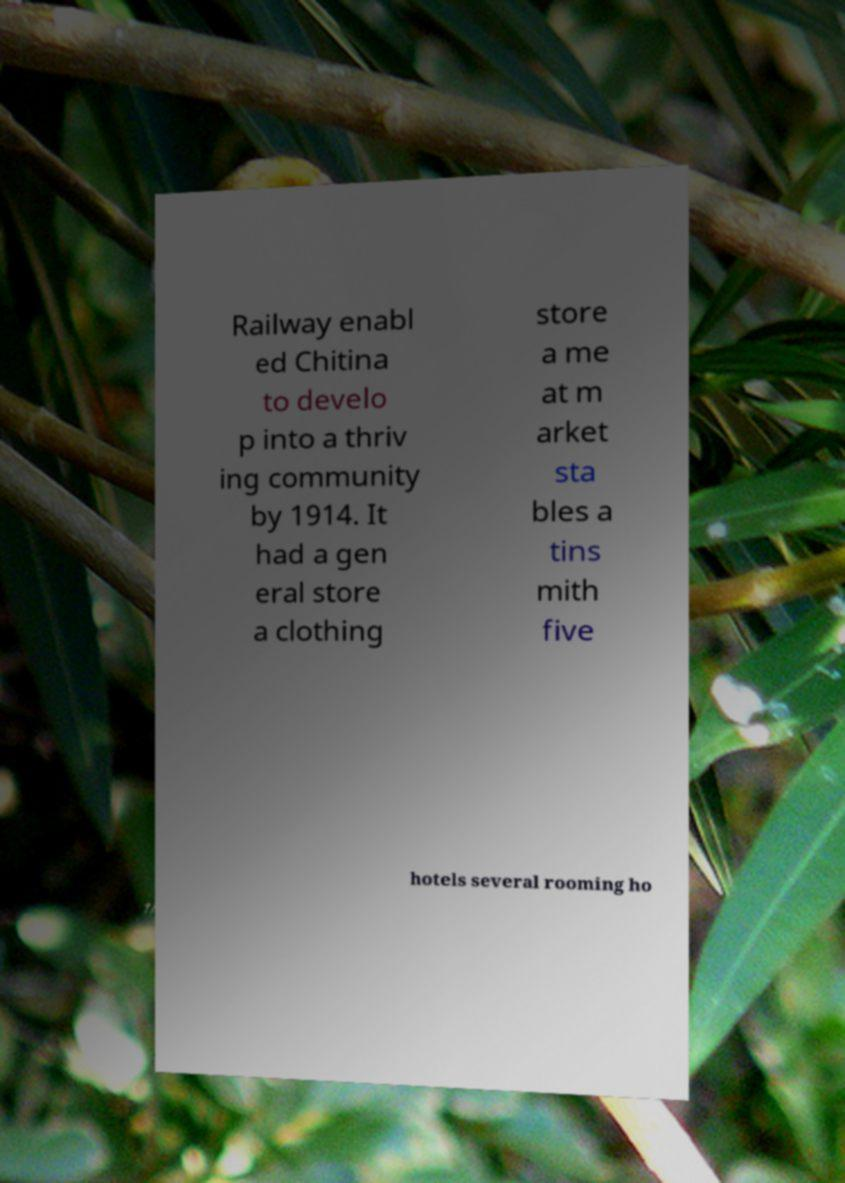Can you accurately transcribe the text from the provided image for me? Railway enabl ed Chitina to develo p into a thriv ing community by 1914. It had a gen eral store a clothing store a me at m arket sta bles a tins mith five hotels several rooming ho 